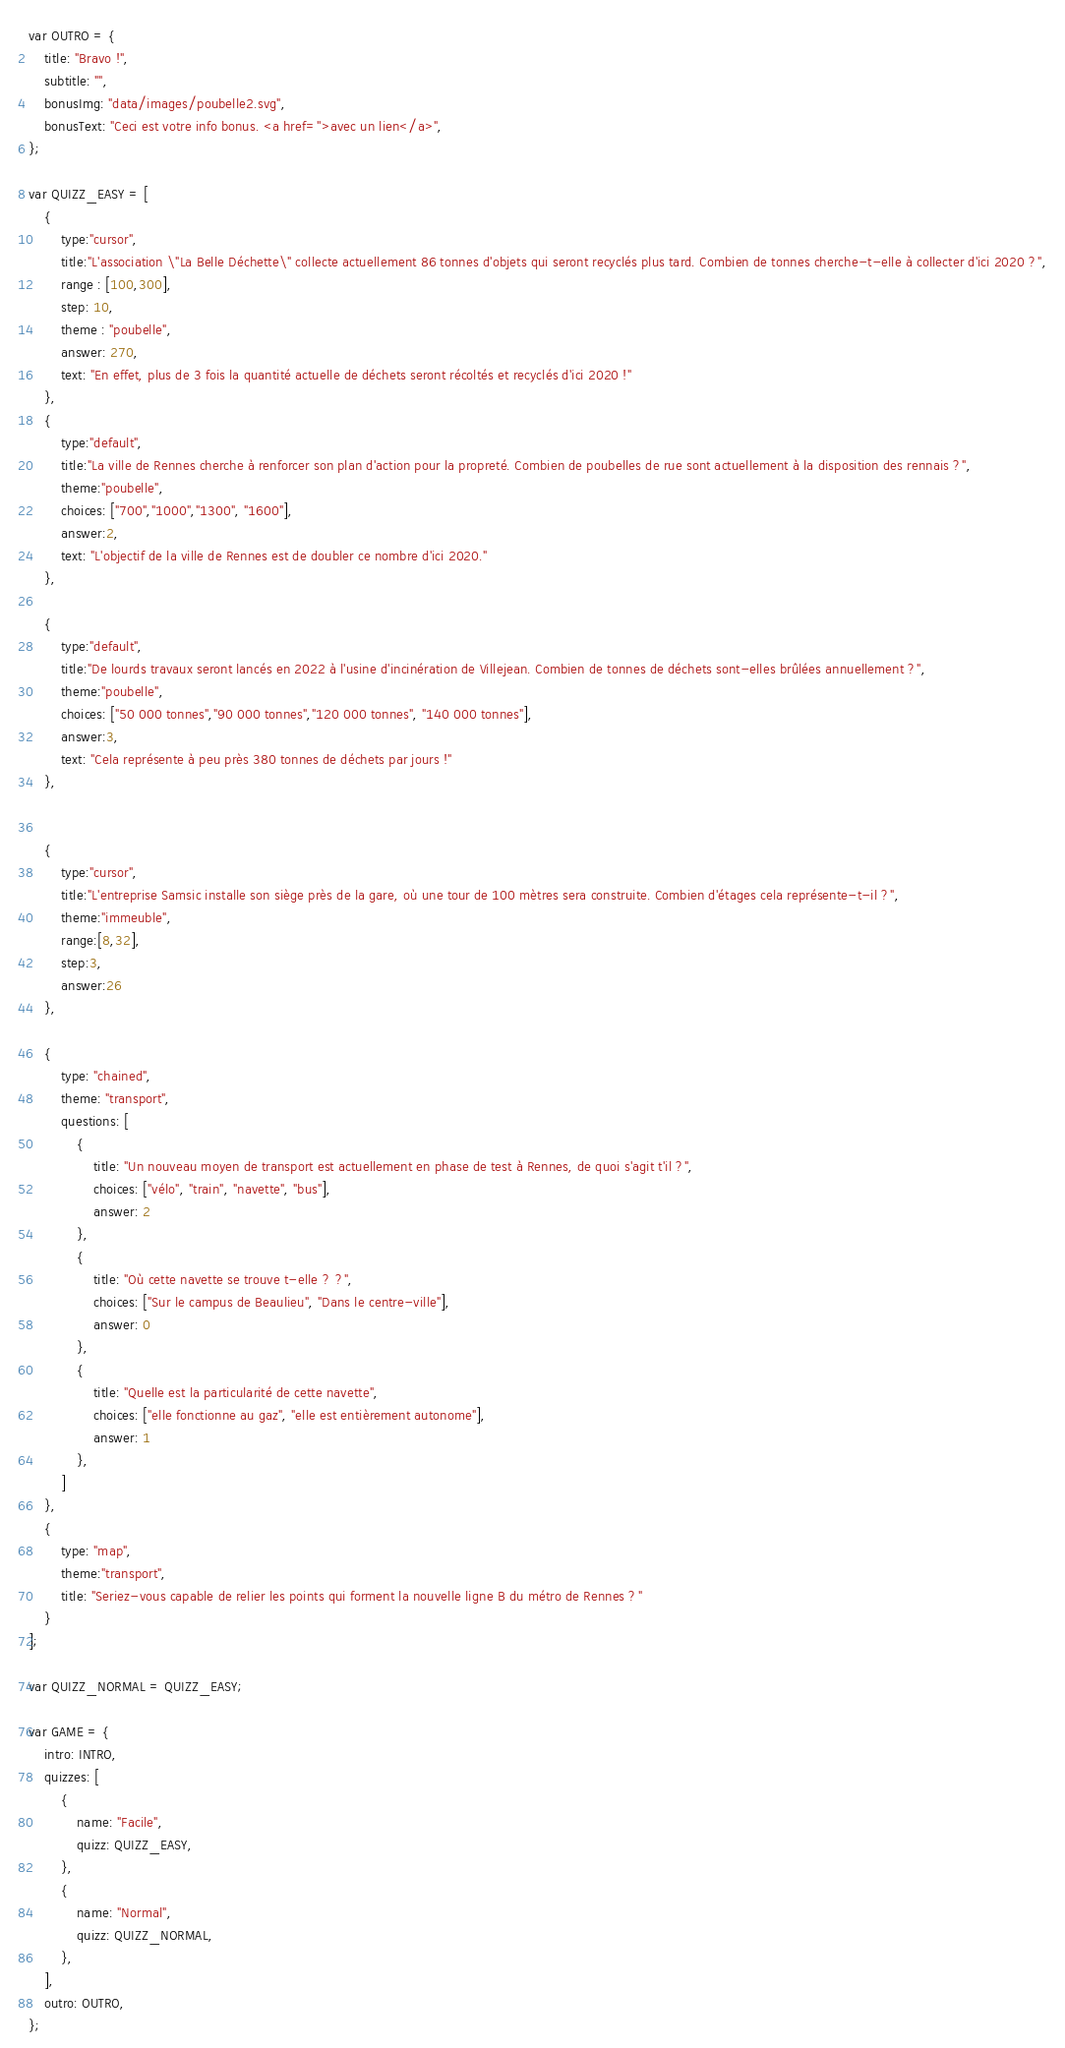Convert code to text. <code><loc_0><loc_0><loc_500><loc_500><_JavaScript_>
var OUTRO = {
    title: "Bravo !",
    subtitle: "",
    bonusImg: "data/images/poubelle2.svg",
    bonusText: "Ceci est votre info bonus. <a href=''>avec un lien</a>",
};

var QUIZZ_EASY = [
    {
        type:"cursor",
        title:"L'association \"La Belle Déchette\" collecte actuellement 86 tonnes d'objets qui seront recyclés plus tard. Combien de tonnes cherche-t-elle à collecter d'ici 2020 ?",
        range : [100,300],
        step: 10,
        theme : "poubelle",
        answer: 270,
        text: "En effet, plus de 3 fois la quantité actuelle de déchets seront récoltés et recyclés d'ici 2020 !"
    },
    {
        type:"default",
        title:"La ville de Rennes cherche à renforcer son plan d'action pour la propreté. Combien de poubelles de rue sont actuellement à la disposition des rennais ?",
        theme:"poubelle",
        choices: ["700","1000","1300", "1600"],
        answer:2,
        text: "L'objectif de la ville de Rennes est de doubler ce nombre d'ici 2020."
    },

    {
        type:"default",
        title:"De lourds travaux seront lancés en 2022 à l'usine d'incinération de Villejean. Combien de tonnes de déchets sont-elles brûlées annuellement ?",
        theme:"poubelle",
        choices: ["50 000 tonnes","90 000 tonnes","120 000 tonnes", "140 000 tonnes"],
        answer:3,
        text: "Cela représente à peu près 380 tonnes de déchets par jours !"
    },


    {
        type:"cursor",
        title:"L'entreprise Samsic installe son siège près de la gare, où une tour de 100 mètres sera construite. Combien d'étages cela représente-t-il ?",
        theme:"immeuble",
        range:[8,32],
        step:3,
        answer:26
    },

    {
        type: "chained",
        theme: "transport",
        questions: [
            {
                title: "Un nouveau moyen de transport est actuellement en phase de test à Rennes, de quoi s'agit t'il ?",
                choices: ["vélo", "train", "navette", "bus"],
                answer: 2
            },
            {
                title: "Où cette navette se trouve t-elle ? ?",
                choices: ["Sur le campus de Beaulieu", "Dans le centre-ville"],
                answer: 0
            },
            {
                title: "Quelle est la particularité de cette navette",
                choices: ["elle fonctionne au gaz", "elle est entièrement autonome"],
                answer: 1
            },
        ]
    },
    {
        type: "map",
        theme:"transport",
        title: "Seriez-vous capable de relier les points qui forment la nouvelle ligne B du métro de Rennes ?"
    }
];

var QUIZZ_NORMAL = QUIZZ_EASY;

var GAME = {
    intro: INTRO,
    quizzes: [
        {
            name: "Facile",
            quizz: QUIZZ_EASY,
        },
        {
            name: "Normal",
            quizz: QUIZZ_NORMAL,
        },
    ],
    outro: OUTRO,
};

</code> 